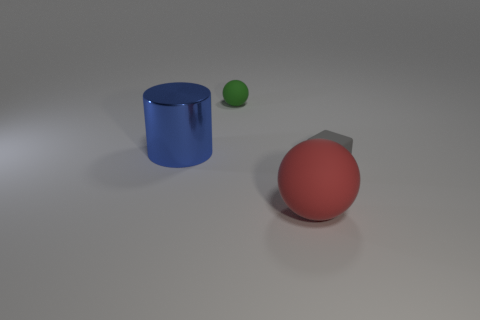Add 3 large metal cylinders. How many objects exist? 7 Subtract all large blue shiny cylinders. Subtract all red things. How many objects are left? 2 Add 4 red matte spheres. How many red matte spheres are left? 5 Add 2 small brown balls. How many small brown balls exist? 2 Subtract 1 gray cubes. How many objects are left? 3 Subtract all cubes. How many objects are left? 3 Subtract all cyan balls. Subtract all purple cylinders. How many balls are left? 2 Subtract all red spheres. How many cyan cubes are left? 0 